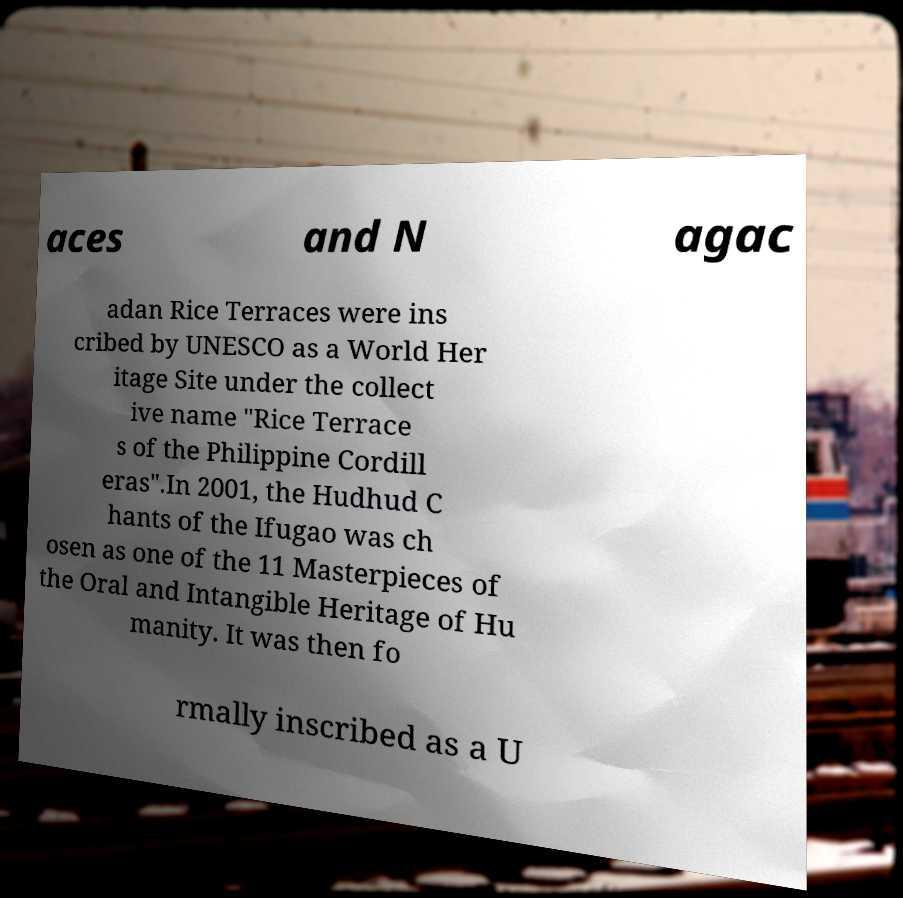Could you extract and type out the text from this image? aces and N agac adan Rice Terraces were ins cribed by UNESCO as a World Her itage Site under the collect ive name "Rice Terrace s of the Philippine Cordill eras".In 2001, the Hudhud C hants of the Ifugao was ch osen as one of the 11 Masterpieces of the Oral and Intangible Heritage of Hu manity. It was then fo rmally inscribed as a U 